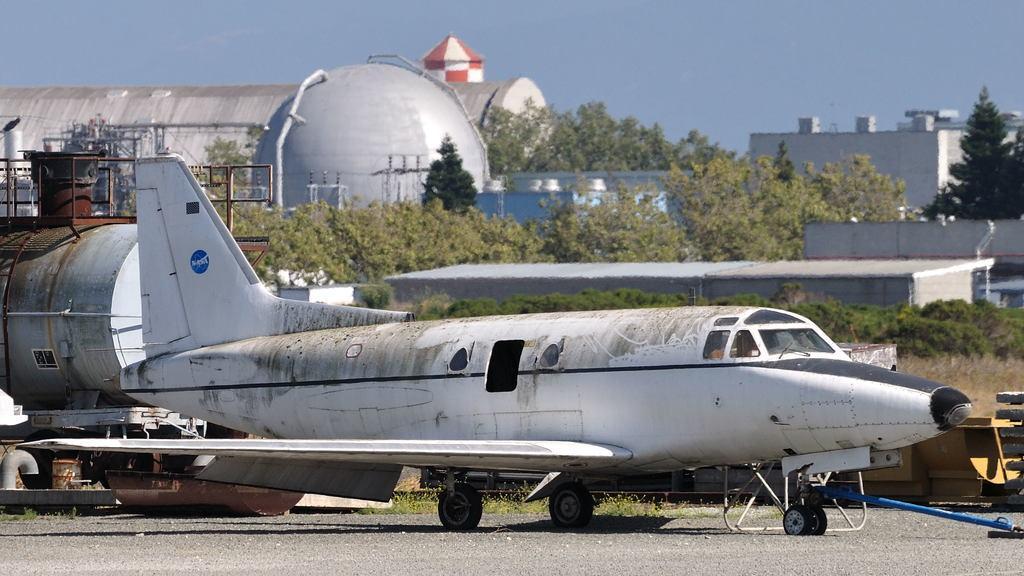Please provide a concise description of this image. In this picture we can observe an airplane on the runway. There is some grass and plants on the ground. We can observe buildings and trees. In the background there is a sky. 